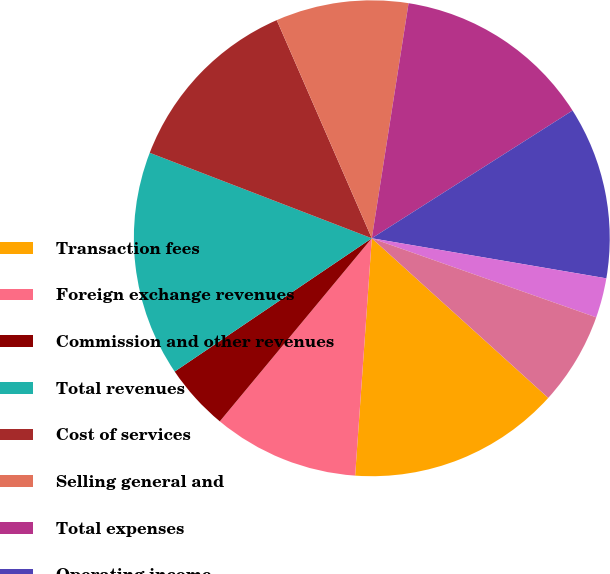Convert chart. <chart><loc_0><loc_0><loc_500><loc_500><pie_chart><fcel>Transaction fees<fcel>Foreign exchange revenues<fcel>Commission and other revenues<fcel>Total revenues<fcel>Cost of services<fcel>Selling general and<fcel>Total expenses<fcel>Operating income<fcel>Interest income<fcel>Interest expense<nl><fcel>14.41%<fcel>9.91%<fcel>4.51%<fcel>15.31%<fcel>12.61%<fcel>9.01%<fcel>13.51%<fcel>11.71%<fcel>2.7%<fcel>6.31%<nl></chart> 